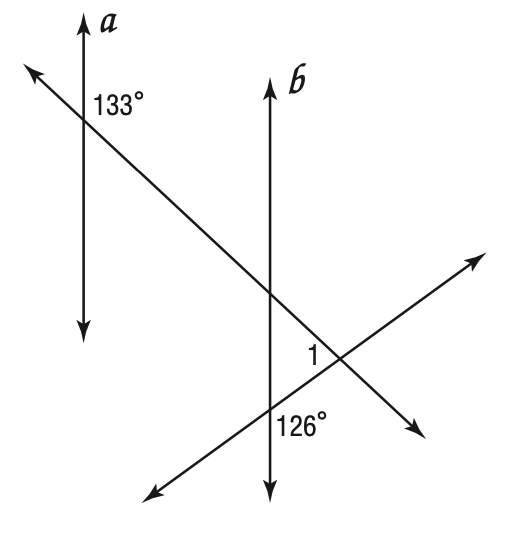Answer the mathemtical geometry problem and directly provide the correct option letter.
Question: Given a \parallel b, find m \angle 1.
Choices: A: 47 B: 54 C: 79 D: 101 C 